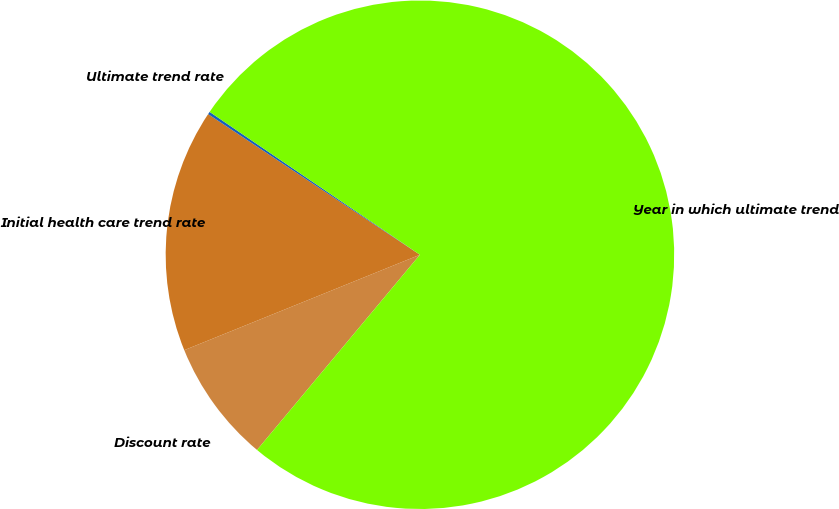Convert chart. <chart><loc_0><loc_0><loc_500><loc_500><pie_chart><fcel>Discount rate<fcel>Initial health care trend rate<fcel>Ultimate trend rate<fcel>Year in which ultimate trend<nl><fcel>7.81%<fcel>15.45%<fcel>0.17%<fcel>76.57%<nl></chart> 